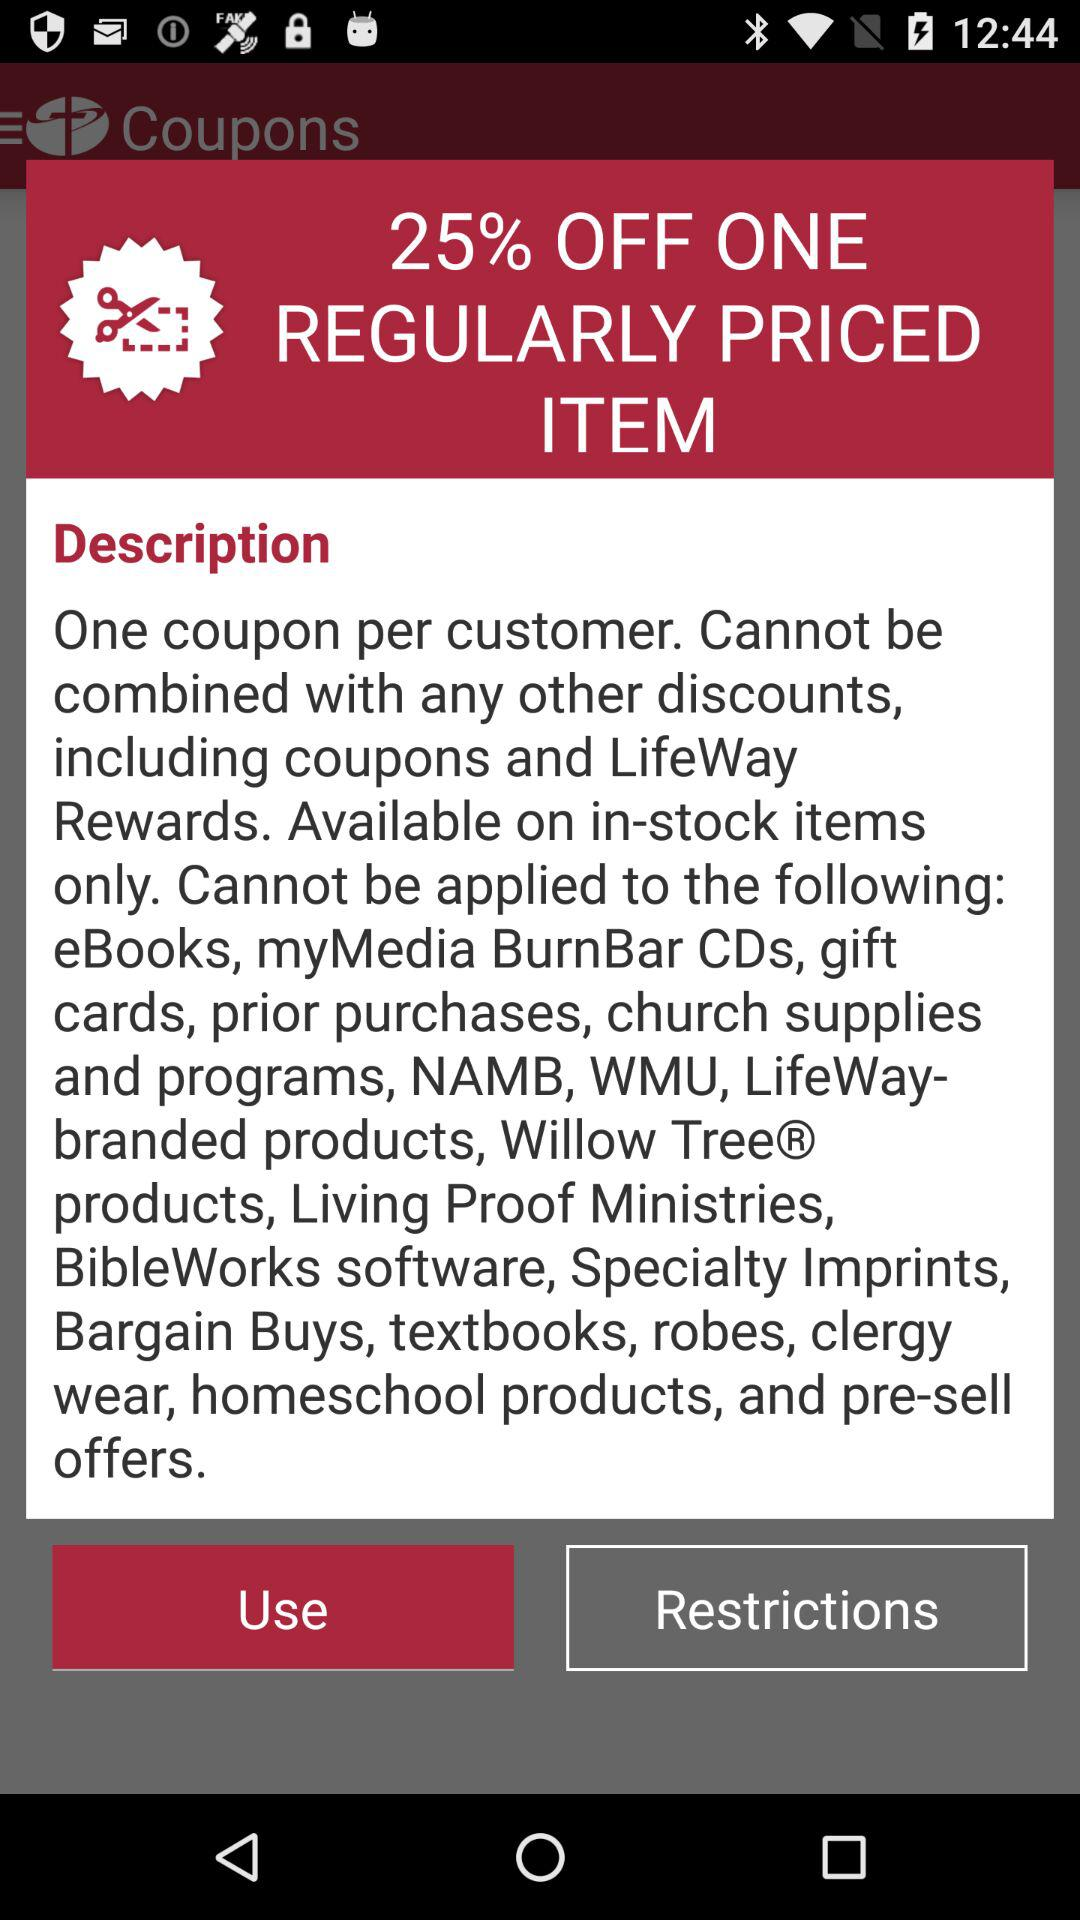How many coupons are there per customer? There is one coupon per customer. 